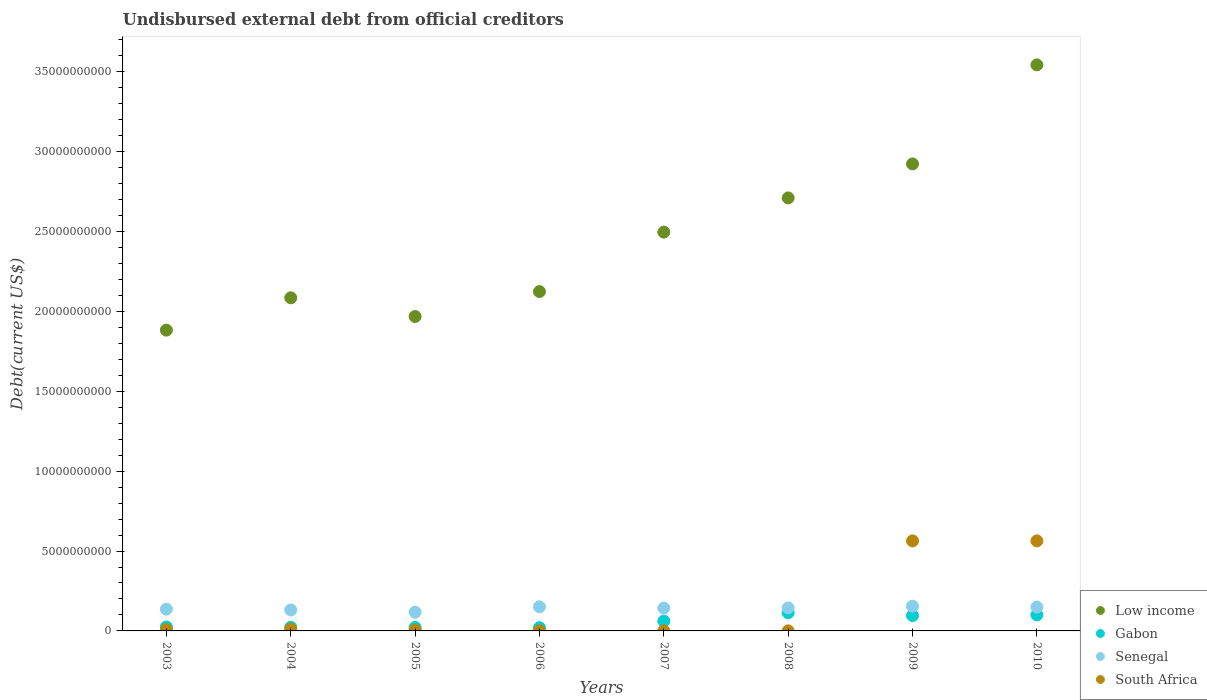What is the total debt in Gabon in 2004?
Offer a terse response. 2.28e+08. Across all years, what is the maximum total debt in Senegal?
Provide a succinct answer. 1.55e+09. Across all years, what is the minimum total debt in South Africa?
Provide a short and direct response. 3.94e+06. In which year was the total debt in Senegal minimum?
Provide a short and direct response. 2005. What is the total total debt in Gabon in the graph?
Provide a short and direct response. 4.61e+09. What is the difference between the total debt in Senegal in 2003 and that in 2004?
Your answer should be very brief. 5.16e+07. What is the difference between the total debt in Senegal in 2004 and the total debt in Gabon in 2009?
Your answer should be very brief. 3.48e+08. What is the average total debt in Senegal per year?
Provide a short and direct response. 1.41e+09. In the year 2005, what is the difference between the total debt in Low income and total debt in Gabon?
Keep it short and to the point. 1.95e+1. What is the ratio of the total debt in South Africa in 2007 to that in 2008?
Provide a succinct answer. 1.79. Is the total debt in Gabon in 2003 less than that in 2004?
Your answer should be very brief. No. What is the difference between the highest and the second highest total debt in Gabon?
Offer a terse response. 1.39e+08. What is the difference between the highest and the lowest total debt in Senegal?
Give a very brief answer. 3.78e+08. Is the sum of the total debt in Senegal in 2003 and 2006 greater than the maximum total debt in Low income across all years?
Offer a terse response. No. Is it the case that in every year, the sum of the total debt in Low income and total debt in South Africa  is greater than the total debt in Gabon?
Make the answer very short. Yes. Does the total debt in Gabon monotonically increase over the years?
Your response must be concise. No. Is the total debt in Senegal strictly greater than the total debt in South Africa over the years?
Offer a terse response. No. How many dotlines are there?
Your answer should be compact. 4. How many years are there in the graph?
Make the answer very short. 8. Does the graph contain grids?
Your answer should be very brief. No. Where does the legend appear in the graph?
Keep it short and to the point. Bottom right. How many legend labels are there?
Offer a terse response. 4. How are the legend labels stacked?
Your response must be concise. Vertical. What is the title of the graph?
Your response must be concise. Undisbursed external debt from official creditors. Does "Congo (Republic)" appear as one of the legend labels in the graph?
Your answer should be compact. No. What is the label or title of the Y-axis?
Ensure brevity in your answer.  Debt(current US$). What is the Debt(current US$) in Low income in 2003?
Your answer should be very brief. 1.88e+1. What is the Debt(current US$) in Gabon in 2003?
Offer a terse response. 2.49e+08. What is the Debt(current US$) of Senegal in 2003?
Give a very brief answer. 1.36e+09. What is the Debt(current US$) in South Africa in 2003?
Give a very brief answer. 8.62e+07. What is the Debt(current US$) of Low income in 2004?
Your answer should be very brief. 2.09e+1. What is the Debt(current US$) of Gabon in 2004?
Your response must be concise. 2.28e+08. What is the Debt(current US$) of Senegal in 2004?
Offer a very short reply. 1.31e+09. What is the Debt(current US$) in South Africa in 2004?
Make the answer very short. 1.16e+08. What is the Debt(current US$) of Low income in 2005?
Keep it short and to the point. 1.97e+1. What is the Debt(current US$) of Gabon in 2005?
Offer a terse response. 2.15e+08. What is the Debt(current US$) of Senegal in 2005?
Ensure brevity in your answer.  1.17e+09. What is the Debt(current US$) of South Africa in 2005?
Your answer should be compact. 5.70e+07. What is the Debt(current US$) of Low income in 2006?
Your answer should be very brief. 2.12e+1. What is the Debt(current US$) in Gabon in 2006?
Offer a terse response. 2.02e+08. What is the Debt(current US$) in Senegal in 2006?
Give a very brief answer. 1.51e+09. What is the Debt(current US$) of South Africa in 2006?
Make the answer very short. 7.04e+06. What is the Debt(current US$) of Low income in 2007?
Provide a short and direct response. 2.50e+1. What is the Debt(current US$) of Gabon in 2007?
Your answer should be compact. 6.12e+08. What is the Debt(current US$) of Senegal in 2007?
Keep it short and to the point. 1.43e+09. What is the Debt(current US$) of South Africa in 2007?
Make the answer very short. 7.04e+06. What is the Debt(current US$) of Low income in 2008?
Make the answer very short. 2.71e+1. What is the Debt(current US$) of Gabon in 2008?
Offer a terse response. 1.14e+09. What is the Debt(current US$) of Senegal in 2008?
Provide a short and direct response. 1.44e+09. What is the Debt(current US$) of South Africa in 2008?
Keep it short and to the point. 3.94e+06. What is the Debt(current US$) of Low income in 2009?
Your response must be concise. 2.92e+1. What is the Debt(current US$) in Gabon in 2009?
Offer a terse response. 9.63e+08. What is the Debt(current US$) of Senegal in 2009?
Give a very brief answer. 1.55e+09. What is the Debt(current US$) of South Africa in 2009?
Ensure brevity in your answer.  5.64e+09. What is the Debt(current US$) of Low income in 2010?
Your answer should be very brief. 3.54e+1. What is the Debt(current US$) of Gabon in 2010?
Give a very brief answer. 1.00e+09. What is the Debt(current US$) in Senegal in 2010?
Your answer should be very brief. 1.49e+09. What is the Debt(current US$) of South Africa in 2010?
Ensure brevity in your answer.  5.64e+09. Across all years, what is the maximum Debt(current US$) of Low income?
Your response must be concise. 3.54e+1. Across all years, what is the maximum Debt(current US$) of Gabon?
Provide a short and direct response. 1.14e+09. Across all years, what is the maximum Debt(current US$) of Senegal?
Your answer should be compact. 1.55e+09. Across all years, what is the maximum Debt(current US$) of South Africa?
Keep it short and to the point. 5.64e+09. Across all years, what is the minimum Debt(current US$) in Low income?
Offer a very short reply. 1.88e+1. Across all years, what is the minimum Debt(current US$) of Gabon?
Your response must be concise. 2.02e+08. Across all years, what is the minimum Debt(current US$) in Senegal?
Ensure brevity in your answer.  1.17e+09. Across all years, what is the minimum Debt(current US$) of South Africa?
Make the answer very short. 3.94e+06. What is the total Debt(current US$) in Low income in the graph?
Keep it short and to the point. 1.97e+11. What is the total Debt(current US$) in Gabon in the graph?
Your answer should be very brief. 4.61e+09. What is the total Debt(current US$) of Senegal in the graph?
Provide a succinct answer. 1.13e+1. What is the total Debt(current US$) of South Africa in the graph?
Offer a very short reply. 1.16e+1. What is the difference between the Debt(current US$) of Low income in 2003 and that in 2004?
Offer a very short reply. -2.02e+09. What is the difference between the Debt(current US$) of Gabon in 2003 and that in 2004?
Offer a terse response. 2.06e+07. What is the difference between the Debt(current US$) in Senegal in 2003 and that in 2004?
Make the answer very short. 5.16e+07. What is the difference between the Debt(current US$) of South Africa in 2003 and that in 2004?
Provide a succinct answer. -3.02e+07. What is the difference between the Debt(current US$) of Low income in 2003 and that in 2005?
Your response must be concise. -8.53e+08. What is the difference between the Debt(current US$) of Gabon in 2003 and that in 2005?
Your answer should be compact. 3.31e+07. What is the difference between the Debt(current US$) of Senegal in 2003 and that in 2005?
Offer a terse response. 1.92e+08. What is the difference between the Debt(current US$) in South Africa in 2003 and that in 2005?
Ensure brevity in your answer.  2.91e+07. What is the difference between the Debt(current US$) in Low income in 2003 and that in 2006?
Offer a very short reply. -2.41e+09. What is the difference between the Debt(current US$) in Gabon in 2003 and that in 2006?
Provide a succinct answer. 4.68e+07. What is the difference between the Debt(current US$) in Senegal in 2003 and that in 2006?
Provide a succinct answer. -1.49e+08. What is the difference between the Debt(current US$) of South Africa in 2003 and that in 2006?
Make the answer very short. 7.91e+07. What is the difference between the Debt(current US$) of Low income in 2003 and that in 2007?
Provide a succinct answer. -6.13e+09. What is the difference between the Debt(current US$) in Gabon in 2003 and that in 2007?
Offer a terse response. -3.63e+08. What is the difference between the Debt(current US$) of Senegal in 2003 and that in 2007?
Provide a succinct answer. -7.01e+07. What is the difference between the Debt(current US$) of South Africa in 2003 and that in 2007?
Give a very brief answer. 7.91e+07. What is the difference between the Debt(current US$) in Low income in 2003 and that in 2008?
Give a very brief answer. -8.28e+09. What is the difference between the Debt(current US$) of Gabon in 2003 and that in 2008?
Offer a terse response. -8.93e+08. What is the difference between the Debt(current US$) in Senegal in 2003 and that in 2008?
Offer a terse response. -7.77e+07. What is the difference between the Debt(current US$) in South Africa in 2003 and that in 2008?
Make the answer very short. 8.22e+07. What is the difference between the Debt(current US$) of Low income in 2003 and that in 2009?
Your answer should be very brief. -1.04e+1. What is the difference between the Debt(current US$) of Gabon in 2003 and that in 2009?
Ensure brevity in your answer.  -7.14e+08. What is the difference between the Debt(current US$) in Senegal in 2003 and that in 2009?
Provide a succinct answer. -1.86e+08. What is the difference between the Debt(current US$) in South Africa in 2003 and that in 2009?
Offer a terse response. -5.55e+09. What is the difference between the Debt(current US$) in Low income in 2003 and that in 2010?
Provide a short and direct response. -1.66e+1. What is the difference between the Debt(current US$) of Gabon in 2003 and that in 2010?
Your response must be concise. -7.54e+08. What is the difference between the Debt(current US$) of Senegal in 2003 and that in 2010?
Your answer should be very brief. -1.30e+08. What is the difference between the Debt(current US$) of South Africa in 2003 and that in 2010?
Provide a short and direct response. -5.55e+09. What is the difference between the Debt(current US$) in Low income in 2004 and that in 2005?
Make the answer very short. 1.17e+09. What is the difference between the Debt(current US$) of Gabon in 2004 and that in 2005?
Offer a very short reply. 1.24e+07. What is the difference between the Debt(current US$) in Senegal in 2004 and that in 2005?
Keep it short and to the point. 1.40e+08. What is the difference between the Debt(current US$) in South Africa in 2004 and that in 2005?
Your answer should be very brief. 5.94e+07. What is the difference between the Debt(current US$) of Low income in 2004 and that in 2006?
Provide a succinct answer. -3.89e+08. What is the difference between the Debt(current US$) in Gabon in 2004 and that in 2006?
Offer a very short reply. 2.61e+07. What is the difference between the Debt(current US$) of Senegal in 2004 and that in 2006?
Make the answer very short. -2.00e+08. What is the difference between the Debt(current US$) of South Africa in 2004 and that in 2006?
Offer a very short reply. 1.09e+08. What is the difference between the Debt(current US$) in Low income in 2004 and that in 2007?
Keep it short and to the point. -4.11e+09. What is the difference between the Debt(current US$) of Gabon in 2004 and that in 2007?
Offer a very short reply. -3.84e+08. What is the difference between the Debt(current US$) in Senegal in 2004 and that in 2007?
Keep it short and to the point. -1.22e+08. What is the difference between the Debt(current US$) in South Africa in 2004 and that in 2007?
Make the answer very short. 1.09e+08. What is the difference between the Debt(current US$) in Low income in 2004 and that in 2008?
Ensure brevity in your answer.  -6.25e+09. What is the difference between the Debt(current US$) in Gabon in 2004 and that in 2008?
Ensure brevity in your answer.  -9.14e+08. What is the difference between the Debt(current US$) in Senegal in 2004 and that in 2008?
Give a very brief answer. -1.29e+08. What is the difference between the Debt(current US$) of South Africa in 2004 and that in 2008?
Offer a terse response. 1.12e+08. What is the difference between the Debt(current US$) in Low income in 2004 and that in 2009?
Your answer should be very brief. -8.38e+09. What is the difference between the Debt(current US$) in Gabon in 2004 and that in 2009?
Provide a short and direct response. -7.35e+08. What is the difference between the Debt(current US$) of Senegal in 2004 and that in 2009?
Offer a very short reply. -2.38e+08. What is the difference between the Debt(current US$) of South Africa in 2004 and that in 2009?
Keep it short and to the point. -5.52e+09. What is the difference between the Debt(current US$) in Low income in 2004 and that in 2010?
Your response must be concise. -1.46e+1. What is the difference between the Debt(current US$) in Gabon in 2004 and that in 2010?
Provide a short and direct response. -7.75e+08. What is the difference between the Debt(current US$) in Senegal in 2004 and that in 2010?
Your answer should be very brief. -1.81e+08. What is the difference between the Debt(current US$) in South Africa in 2004 and that in 2010?
Your response must be concise. -5.52e+09. What is the difference between the Debt(current US$) in Low income in 2005 and that in 2006?
Provide a succinct answer. -1.56e+09. What is the difference between the Debt(current US$) of Gabon in 2005 and that in 2006?
Make the answer very short. 1.37e+07. What is the difference between the Debt(current US$) in Senegal in 2005 and that in 2006?
Your answer should be very brief. -3.40e+08. What is the difference between the Debt(current US$) in Low income in 2005 and that in 2007?
Ensure brevity in your answer.  -5.28e+09. What is the difference between the Debt(current US$) in Gabon in 2005 and that in 2007?
Your answer should be very brief. -3.96e+08. What is the difference between the Debt(current US$) in Senegal in 2005 and that in 2007?
Provide a succinct answer. -2.62e+08. What is the difference between the Debt(current US$) in South Africa in 2005 and that in 2007?
Offer a very short reply. 5.00e+07. What is the difference between the Debt(current US$) in Low income in 2005 and that in 2008?
Make the answer very short. -7.42e+09. What is the difference between the Debt(current US$) of Gabon in 2005 and that in 2008?
Provide a succinct answer. -9.26e+08. What is the difference between the Debt(current US$) of Senegal in 2005 and that in 2008?
Your response must be concise. -2.70e+08. What is the difference between the Debt(current US$) of South Africa in 2005 and that in 2008?
Offer a terse response. 5.31e+07. What is the difference between the Debt(current US$) of Low income in 2005 and that in 2009?
Your response must be concise. -9.55e+09. What is the difference between the Debt(current US$) of Gabon in 2005 and that in 2009?
Offer a terse response. -7.47e+08. What is the difference between the Debt(current US$) in Senegal in 2005 and that in 2009?
Your response must be concise. -3.78e+08. What is the difference between the Debt(current US$) of South Africa in 2005 and that in 2009?
Ensure brevity in your answer.  -5.58e+09. What is the difference between the Debt(current US$) of Low income in 2005 and that in 2010?
Offer a terse response. -1.58e+1. What is the difference between the Debt(current US$) in Gabon in 2005 and that in 2010?
Your answer should be very brief. -7.87e+08. What is the difference between the Debt(current US$) in Senegal in 2005 and that in 2010?
Keep it short and to the point. -3.22e+08. What is the difference between the Debt(current US$) of South Africa in 2005 and that in 2010?
Provide a short and direct response. -5.58e+09. What is the difference between the Debt(current US$) in Low income in 2006 and that in 2007?
Offer a terse response. -3.72e+09. What is the difference between the Debt(current US$) in Gabon in 2006 and that in 2007?
Your answer should be compact. -4.10e+08. What is the difference between the Debt(current US$) of Senegal in 2006 and that in 2007?
Give a very brief answer. 7.86e+07. What is the difference between the Debt(current US$) in South Africa in 2006 and that in 2007?
Make the answer very short. 0. What is the difference between the Debt(current US$) in Low income in 2006 and that in 2008?
Your answer should be very brief. -5.86e+09. What is the difference between the Debt(current US$) in Gabon in 2006 and that in 2008?
Provide a short and direct response. -9.40e+08. What is the difference between the Debt(current US$) in Senegal in 2006 and that in 2008?
Provide a succinct answer. 7.10e+07. What is the difference between the Debt(current US$) of South Africa in 2006 and that in 2008?
Offer a very short reply. 3.10e+06. What is the difference between the Debt(current US$) in Low income in 2006 and that in 2009?
Offer a very short reply. -7.99e+09. What is the difference between the Debt(current US$) of Gabon in 2006 and that in 2009?
Provide a succinct answer. -7.61e+08. What is the difference between the Debt(current US$) in Senegal in 2006 and that in 2009?
Keep it short and to the point. -3.77e+07. What is the difference between the Debt(current US$) of South Africa in 2006 and that in 2009?
Offer a terse response. -5.63e+09. What is the difference between the Debt(current US$) of Low income in 2006 and that in 2010?
Ensure brevity in your answer.  -1.42e+1. What is the difference between the Debt(current US$) of Gabon in 2006 and that in 2010?
Your answer should be very brief. -8.01e+08. What is the difference between the Debt(current US$) in Senegal in 2006 and that in 2010?
Your answer should be very brief. 1.87e+07. What is the difference between the Debt(current US$) in South Africa in 2006 and that in 2010?
Offer a terse response. -5.63e+09. What is the difference between the Debt(current US$) in Low income in 2007 and that in 2008?
Keep it short and to the point. -2.14e+09. What is the difference between the Debt(current US$) in Gabon in 2007 and that in 2008?
Provide a short and direct response. -5.30e+08. What is the difference between the Debt(current US$) of Senegal in 2007 and that in 2008?
Your answer should be compact. -7.61e+06. What is the difference between the Debt(current US$) in South Africa in 2007 and that in 2008?
Provide a succinct answer. 3.10e+06. What is the difference between the Debt(current US$) in Low income in 2007 and that in 2009?
Your response must be concise. -4.27e+09. What is the difference between the Debt(current US$) in Gabon in 2007 and that in 2009?
Offer a very short reply. -3.51e+08. What is the difference between the Debt(current US$) of Senegal in 2007 and that in 2009?
Give a very brief answer. -1.16e+08. What is the difference between the Debt(current US$) in South Africa in 2007 and that in 2009?
Give a very brief answer. -5.63e+09. What is the difference between the Debt(current US$) in Low income in 2007 and that in 2010?
Make the answer very short. -1.05e+1. What is the difference between the Debt(current US$) in Gabon in 2007 and that in 2010?
Provide a succinct answer. -3.91e+08. What is the difference between the Debt(current US$) in Senegal in 2007 and that in 2010?
Provide a short and direct response. -5.98e+07. What is the difference between the Debt(current US$) of South Africa in 2007 and that in 2010?
Make the answer very short. -5.63e+09. What is the difference between the Debt(current US$) in Low income in 2008 and that in 2009?
Provide a short and direct response. -2.13e+09. What is the difference between the Debt(current US$) of Gabon in 2008 and that in 2009?
Your response must be concise. 1.79e+08. What is the difference between the Debt(current US$) in Senegal in 2008 and that in 2009?
Your answer should be very brief. -1.09e+08. What is the difference between the Debt(current US$) of South Africa in 2008 and that in 2009?
Your response must be concise. -5.63e+09. What is the difference between the Debt(current US$) of Low income in 2008 and that in 2010?
Provide a succinct answer. -8.33e+09. What is the difference between the Debt(current US$) in Gabon in 2008 and that in 2010?
Give a very brief answer. 1.39e+08. What is the difference between the Debt(current US$) of Senegal in 2008 and that in 2010?
Keep it short and to the point. -5.22e+07. What is the difference between the Debt(current US$) in South Africa in 2008 and that in 2010?
Offer a very short reply. -5.63e+09. What is the difference between the Debt(current US$) in Low income in 2009 and that in 2010?
Provide a short and direct response. -6.20e+09. What is the difference between the Debt(current US$) in Gabon in 2009 and that in 2010?
Provide a succinct answer. -4.02e+07. What is the difference between the Debt(current US$) of Senegal in 2009 and that in 2010?
Your answer should be compact. 5.64e+07. What is the difference between the Debt(current US$) in South Africa in 2009 and that in 2010?
Your answer should be very brief. -1.40e+06. What is the difference between the Debt(current US$) in Low income in 2003 and the Debt(current US$) in Gabon in 2004?
Give a very brief answer. 1.86e+1. What is the difference between the Debt(current US$) of Low income in 2003 and the Debt(current US$) of Senegal in 2004?
Ensure brevity in your answer.  1.75e+1. What is the difference between the Debt(current US$) of Low income in 2003 and the Debt(current US$) of South Africa in 2004?
Provide a short and direct response. 1.87e+1. What is the difference between the Debt(current US$) of Gabon in 2003 and the Debt(current US$) of Senegal in 2004?
Your response must be concise. -1.06e+09. What is the difference between the Debt(current US$) in Gabon in 2003 and the Debt(current US$) in South Africa in 2004?
Offer a very short reply. 1.32e+08. What is the difference between the Debt(current US$) of Senegal in 2003 and the Debt(current US$) of South Africa in 2004?
Ensure brevity in your answer.  1.25e+09. What is the difference between the Debt(current US$) in Low income in 2003 and the Debt(current US$) in Gabon in 2005?
Your answer should be very brief. 1.86e+1. What is the difference between the Debt(current US$) of Low income in 2003 and the Debt(current US$) of Senegal in 2005?
Keep it short and to the point. 1.77e+1. What is the difference between the Debt(current US$) in Low income in 2003 and the Debt(current US$) in South Africa in 2005?
Provide a short and direct response. 1.88e+1. What is the difference between the Debt(current US$) in Gabon in 2003 and the Debt(current US$) in Senegal in 2005?
Make the answer very short. -9.22e+08. What is the difference between the Debt(current US$) in Gabon in 2003 and the Debt(current US$) in South Africa in 2005?
Your answer should be compact. 1.92e+08. What is the difference between the Debt(current US$) of Senegal in 2003 and the Debt(current US$) of South Africa in 2005?
Offer a very short reply. 1.31e+09. What is the difference between the Debt(current US$) of Low income in 2003 and the Debt(current US$) of Gabon in 2006?
Your response must be concise. 1.86e+1. What is the difference between the Debt(current US$) in Low income in 2003 and the Debt(current US$) in Senegal in 2006?
Offer a very short reply. 1.73e+1. What is the difference between the Debt(current US$) in Low income in 2003 and the Debt(current US$) in South Africa in 2006?
Your response must be concise. 1.88e+1. What is the difference between the Debt(current US$) in Gabon in 2003 and the Debt(current US$) in Senegal in 2006?
Your answer should be very brief. -1.26e+09. What is the difference between the Debt(current US$) of Gabon in 2003 and the Debt(current US$) of South Africa in 2006?
Make the answer very short. 2.42e+08. What is the difference between the Debt(current US$) in Senegal in 2003 and the Debt(current US$) in South Africa in 2006?
Provide a succinct answer. 1.36e+09. What is the difference between the Debt(current US$) of Low income in 2003 and the Debt(current US$) of Gabon in 2007?
Provide a succinct answer. 1.82e+1. What is the difference between the Debt(current US$) of Low income in 2003 and the Debt(current US$) of Senegal in 2007?
Make the answer very short. 1.74e+1. What is the difference between the Debt(current US$) in Low income in 2003 and the Debt(current US$) in South Africa in 2007?
Offer a very short reply. 1.88e+1. What is the difference between the Debt(current US$) of Gabon in 2003 and the Debt(current US$) of Senegal in 2007?
Provide a short and direct response. -1.18e+09. What is the difference between the Debt(current US$) in Gabon in 2003 and the Debt(current US$) in South Africa in 2007?
Your response must be concise. 2.42e+08. What is the difference between the Debt(current US$) in Senegal in 2003 and the Debt(current US$) in South Africa in 2007?
Give a very brief answer. 1.36e+09. What is the difference between the Debt(current US$) in Low income in 2003 and the Debt(current US$) in Gabon in 2008?
Offer a terse response. 1.77e+1. What is the difference between the Debt(current US$) in Low income in 2003 and the Debt(current US$) in Senegal in 2008?
Provide a succinct answer. 1.74e+1. What is the difference between the Debt(current US$) in Low income in 2003 and the Debt(current US$) in South Africa in 2008?
Provide a succinct answer. 1.88e+1. What is the difference between the Debt(current US$) of Gabon in 2003 and the Debt(current US$) of Senegal in 2008?
Keep it short and to the point. -1.19e+09. What is the difference between the Debt(current US$) of Gabon in 2003 and the Debt(current US$) of South Africa in 2008?
Offer a terse response. 2.45e+08. What is the difference between the Debt(current US$) in Senegal in 2003 and the Debt(current US$) in South Africa in 2008?
Give a very brief answer. 1.36e+09. What is the difference between the Debt(current US$) in Low income in 2003 and the Debt(current US$) in Gabon in 2009?
Keep it short and to the point. 1.79e+1. What is the difference between the Debt(current US$) in Low income in 2003 and the Debt(current US$) in Senegal in 2009?
Offer a very short reply. 1.73e+1. What is the difference between the Debt(current US$) of Low income in 2003 and the Debt(current US$) of South Africa in 2009?
Ensure brevity in your answer.  1.32e+1. What is the difference between the Debt(current US$) in Gabon in 2003 and the Debt(current US$) in Senegal in 2009?
Ensure brevity in your answer.  -1.30e+09. What is the difference between the Debt(current US$) in Gabon in 2003 and the Debt(current US$) in South Africa in 2009?
Offer a terse response. -5.39e+09. What is the difference between the Debt(current US$) of Senegal in 2003 and the Debt(current US$) of South Africa in 2009?
Your response must be concise. -4.27e+09. What is the difference between the Debt(current US$) in Low income in 2003 and the Debt(current US$) in Gabon in 2010?
Provide a short and direct response. 1.78e+1. What is the difference between the Debt(current US$) of Low income in 2003 and the Debt(current US$) of Senegal in 2010?
Your answer should be very brief. 1.73e+1. What is the difference between the Debt(current US$) in Low income in 2003 and the Debt(current US$) in South Africa in 2010?
Your answer should be compact. 1.32e+1. What is the difference between the Debt(current US$) of Gabon in 2003 and the Debt(current US$) of Senegal in 2010?
Ensure brevity in your answer.  -1.24e+09. What is the difference between the Debt(current US$) of Gabon in 2003 and the Debt(current US$) of South Africa in 2010?
Keep it short and to the point. -5.39e+09. What is the difference between the Debt(current US$) of Senegal in 2003 and the Debt(current US$) of South Africa in 2010?
Ensure brevity in your answer.  -4.27e+09. What is the difference between the Debt(current US$) in Low income in 2004 and the Debt(current US$) in Gabon in 2005?
Give a very brief answer. 2.06e+1. What is the difference between the Debt(current US$) of Low income in 2004 and the Debt(current US$) of Senegal in 2005?
Keep it short and to the point. 1.97e+1. What is the difference between the Debt(current US$) in Low income in 2004 and the Debt(current US$) in South Africa in 2005?
Your answer should be compact. 2.08e+1. What is the difference between the Debt(current US$) in Gabon in 2004 and the Debt(current US$) in Senegal in 2005?
Ensure brevity in your answer.  -9.43e+08. What is the difference between the Debt(current US$) in Gabon in 2004 and the Debt(current US$) in South Africa in 2005?
Provide a succinct answer. 1.71e+08. What is the difference between the Debt(current US$) in Senegal in 2004 and the Debt(current US$) in South Africa in 2005?
Make the answer very short. 1.25e+09. What is the difference between the Debt(current US$) of Low income in 2004 and the Debt(current US$) of Gabon in 2006?
Offer a very short reply. 2.07e+1. What is the difference between the Debt(current US$) of Low income in 2004 and the Debt(current US$) of Senegal in 2006?
Give a very brief answer. 1.93e+1. What is the difference between the Debt(current US$) of Low income in 2004 and the Debt(current US$) of South Africa in 2006?
Offer a very short reply. 2.08e+1. What is the difference between the Debt(current US$) of Gabon in 2004 and the Debt(current US$) of Senegal in 2006?
Provide a short and direct response. -1.28e+09. What is the difference between the Debt(current US$) of Gabon in 2004 and the Debt(current US$) of South Africa in 2006?
Your answer should be very brief. 2.21e+08. What is the difference between the Debt(current US$) of Senegal in 2004 and the Debt(current US$) of South Africa in 2006?
Your response must be concise. 1.30e+09. What is the difference between the Debt(current US$) in Low income in 2004 and the Debt(current US$) in Gabon in 2007?
Provide a short and direct response. 2.02e+1. What is the difference between the Debt(current US$) of Low income in 2004 and the Debt(current US$) of Senegal in 2007?
Your answer should be very brief. 1.94e+1. What is the difference between the Debt(current US$) of Low income in 2004 and the Debt(current US$) of South Africa in 2007?
Give a very brief answer. 2.08e+1. What is the difference between the Debt(current US$) of Gabon in 2004 and the Debt(current US$) of Senegal in 2007?
Make the answer very short. -1.20e+09. What is the difference between the Debt(current US$) of Gabon in 2004 and the Debt(current US$) of South Africa in 2007?
Your response must be concise. 2.21e+08. What is the difference between the Debt(current US$) in Senegal in 2004 and the Debt(current US$) in South Africa in 2007?
Offer a terse response. 1.30e+09. What is the difference between the Debt(current US$) of Low income in 2004 and the Debt(current US$) of Gabon in 2008?
Offer a terse response. 1.97e+1. What is the difference between the Debt(current US$) in Low income in 2004 and the Debt(current US$) in Senegal in 2008?
Provide a short and direct response. 1.94e+1. What is the difference between the Debt(current US$) of Low income in 2004 and the Debt(current US$) of South Africa in 2008?
Offer a very short reply. 2.09e+1. What is the difference between the Debt(current US$) in Gabon in 2004 and the Debt(current US$) in Senegal in 2008?
Provide a short and direct response. -1.21e+09. What is the difference between the Debt(current US$) of Gabon in 2004 and the Debt(current US$) of South Africa in 2008?
Provide a succinct answer. 2.24e+08. What is the difference between the Debt(current US$) in Senegal in 2004 and the Debt(current US$) in South Africa in 2008?
Make the answer very short. 1.31e+09. What is the difference between the Debt(current US$) of Low income in 2004 and the Debt(current US$) of Gabon in 2009?
Make the answer very short. 1.99e+1. What is the difference between the Debt(current US$) in Low income in 2004 and the Debt(current US$) in Senegal in 2009?
Make the answer very short. 1.93e+1. What is the difference between the Debt(current US$) in Low income in 2004 and the Debt(current US$) in South Africa in 2009?
Your answer should be compact. 1.52e+1. What is the difference between the Debt(current US$) of Gabon in 2004 and the Debt(current US$) of Senegal in 2009?
Give a very brief answer. -1.32e+09. What is the difference between the Debt(current US$) in Gabon in 2004 and the Debt(current US$) in South Africa in 2009?
Provide a succinct answer. -5.41e+09. What is the difference between the Debt(current US$) of Senegal in 2004 and the Debt(current US$) of South Africa in 2009?
Your answer should be compact. -4.33e+09. What is the difference between the Debt(current US$) of Low income in 2004 and the Debt(current US$) of Gabon in 2010?
Your answer should be compact. 1.99e+1. What is the difference between the Debt(current US$) of Low income in 2004 and the Debt(current US$) of Senegal in 2010?
Your response must be concise. 1.94e+1. What is the difference between the Debt(current US$) of Low income in 2004 and the Debt(current US$) of South Africa in 2010?
Offer a terse response. 1.52e+1. What is the difference between the Debt(current US$) of Gabon in 2004 and the Debt(current US$) of Senegal in 2010?
Your answer should be very brief. -1.26e+09. What is the difference between the Debt(current US$) of Gabon in 2004 and the Debt(current US$) of South Africa in 2010?
Make the answer very short. -5.41e+09. What is the difference between the Debt(current US$) in Senegal in 2004 and the Debt(current US$) in South Africa in 2010?
Provide a short and direct response. -4.33e+09. What is the difference between the Debt(current US$) in Low income in 2005 and the Debt(current US$) in Gabon in 2006?
Your answer should be compact. 1.95e+1. What is the difference between the Debt(current US$) of Low income in 2005 and the Debt(current US$) of Senegal in 2006?
Give a very brief answer. 1.82e+1. What is the difference between the Debt(current US$) of Low income in 2005 and the Debt(current US$) of South Africa in 2006?
Provide a short and direct response. 1.97e+1. What is the difference between the Debt(current US$) of Gabon in 2005 and the Debt(current US$) of Senegal in 2006?
Offer a terse response. -1.30e+09. What is the difference between the Debt(current US$) in Gabon in 2005 and the Debt(current US$) in South Africa in 2006?
Your answer should be compact. 2.08e+08. What is the difference between the Debt(current US$) of Senegal in 2005 and the Debt(current US$) of South Africa in 2006?
Provide a succinct answer. 1.16e+09. What is the difference between the Debt(current US$) of Low income in 2005 and the Debt(current US$) of Gabon in 2007?
Ensure brevity in your answer.  1.91e+1. What is the difference between the Debt(current US$) of Low income in 2005 and the Debt(current US$) of Senegal in 2007?
Make the answer very short. 1.83e+1. What is the difference between the Debt(current US$) in Low income in 2005 and the Debt(current US$) in South Africa in 2007?
Give a very brief answer. 1.97e+1. What is the difference between the Debt(current US$) of Gabon in 2005 and the Debt(current US$) of Senegal in 2007?
Offer a very short reply. -1.22e+09. What is the difference between the Debt(current US$) of Gabon in 2005 and the Debt(current US$) of South Africa in 2007?
Your response must be concise. 2.08e+08. What is the difference between the Debt(current US$) in Senegal in 2005 and the Debt(current US$) in South Africa in 2007?
Provide a succinct answer. 1.16e+09. What is the difference between the Debt(current US$) of Low income in 2005 and the Debt(current US$) of Gabon in 2008?
Keep it short and to the point. 1.85e+1. What is the difference between the Debt(current US$) of Low income in 2005 and the Debt(current US$) of Senegal in 2008?
Provide a succinct answer. 1.82e+1. What is the difference between the Debt(current US$) of Low income in 2005 and the Debt(current US$) of South Africa in 2008?
Keep it short and to the point. 1.97e+1. What is the difference between the Debt(current US$) in Gabon in 2005 and the Debt(current US$) in Senegal in 2008?
Provide a short and direct response. -1.22e+09. What is the difference between the Debt(current US$) of Gabon in 2005 and the Debt(current US$) of South Africa in 2008?
Provide a short and direct response. 2.12e+08. What is the difference between the Debt(current US$) in Senegal in 2005 and the Debt(current US$) in South Africa in 2008?
Provide a short and direct response. 1.17e+09. What is the difference between the Debt(current US$) of Low income in 2005 and the Debt(current US$) of Gabon in 2009?
Your response must be concise. 1.87e+1. What is the difference between the Debt(current US$) of Low income in 2005 and the Debt(current US$) of Senegal in 2009?
Give a very brief answer. 1.81e+1. What is the difference between the Debt(current US$) of Low income in 2005 and the Debt(current US$) of South Africa in 2009?
Make the answer very short. 1.40e+1. What is the difference between the Debt(current US$) in Gabon in 2005 and the Debt(current US$) in Senegal in 2009?
Make the answer very short. -1.33e+09. What is the difference between the Debt(current US$) in Gabon in 2005 and the Debt(current US$) in South Africa in 2009?
Offer a very short reply. -5.42e+09. What is the difference between the Debt(current US$) of Senegal in 2005 and the Debt(current US$) of South Africa in 2009?
Give a very brief answer. -4.47e+09. What is the difference between the Debt(current US$) in Low income in 2005 and the Debt(current US$) in Gabon in 2010?
Offer a very short reply. 1.87e+1. What is the difference between the Debt(current US$) of Low income in 2005 and the Debt(current US$) of Senegal in 2010?
Ensure brevity in your answer.  1.82e+1. What is the difference between the Debt(current US$) in Low income in 2005 and the Debt(current US$) in South Africa in 2010?
Give a very brief answer. 1.40e+1. What is the difference between the Debt(current US$) in Gabon in 2005 and the Debt(current US$) in Senegal in 2010?
Offer a terse response. -1.28e+09. What is the difference between the Debt(current US$) of Gabon in 2005 and the Debt(current US$) of South Africa in 2010?
Provide a short and direct response. -5.42e+09. What is the difference between the Debt(current US$) in Senegal in 2005 and the Debt(current US$) in South Africa in 2010?
Ensure brevity in your answer.  -4.47e+09. What is the difference between the Debt(current US$) of Low income in 2006 and the Debt(current US$) of Gabon in 2007?
Your response must be concise. 2.06e+1. What is the difference between the Debt(current US$) of Low income in 2006 and the Debt(current US$) of Senegal in 2007?
Offer a very short reply. 1.98e+1. What is the difference between the Debt(current US$) in Low income in 2006 and the Debt(current US$) in South Africa in 2007?
Give a very brief answer. 2.12e+1. What is the difference between the Debt(current US$) of Gabon in 2006 and the Debt(current US$) of Senegal in 2007?
Offer a very short reply. -1.23e+09. What is the difference between the Debt(current US$) of Gabon in 2006 and the Debt(current US$) of South Africa in 2007?
Your answer should be very brief. 1.95e+08. What is the difference between the Debt(current US$) in Senegal in 2006 and the Debt(current US$) in South Africa in 2007?
Provide a short and direct response. 1.50e+09. What is the difference between the Debt(current US$) of Low income in 2006 and the Debt(current US$) of Gabon in 2008?
Ensure brevity in your answer.  2.01e+1. What is the difference between the Debt(current US$) of Low income in 2006 and the Debt(current US$) of Senegal in 2008?
Offer a very short reply. 1.98e+1. What is the difference between the Debt(current US$) of Low income in 2006 and the Debt(current US$) of South Africa in 2008?
Offer a very short reply. 2.12e+1. What is the difference between the Debt(current US$) of Gabon in 2006 and the Debt(current US$) of Senegal in 2008?
Keep it short and to the point. -1.24e+09. What is the difference between the Debt(current US$) of Gabon in 2006 and the Debt(current US$) of South Africa in 2008?
Your response must be concise. 1.98e+08. What is the difference between the Debt(current US$) in Senegal in 2006 and the Debt(current US$) in South Africa in 2008?
Ensure brevity in your answer.  1.51e+09. What is the difference between the Debt(current US$) in Low income in 2006 and the Debt(current US$) in Gabon in 2009?
Make the answer very short. 2.03e+1. What is the difference between the Debt(current US$) of Low income in 2006 and the Debt(current US$) of Senegal in 2009?
Your response must be concise. 1.97e+1. What is the difference between the Debt(current US$) in Low income in 2006 and the Debt(current US$) in South Africa in 2009?
Ensure brevity in your answer.  1.56e+1. What is the difference between the Debt(current US$) in Gabon in 2006 and the Debt(current US$) in Senegal in 2009?
Your response must be concise. -1.35e+09. What is the difference between the Debt(current US$) of Gabon in 2006 and the Debt(current US$) of South Africa in 2009?
Your answer should be very brief. -5.43e+09. What is the difference between the Debt(current US$) in Senegal in 2006 and the Debt(current US$) in South Africa in 2009?
Offer a terse response. -4.12e+09. What is the difference between the Debt(current US$) in Low income in 2006 and the Debt(current US$) in Gabon in 2010?
Your response must be concise. 2.02e+1. What is the difference between the Debt(current US$) of Low income in 2006 and the Debt(current US$) of Senegal in 2010?
Offer a very short reply. 1.98e+1. What is the difference between the Debt(current US$) in Low income in 2006 and the Debt(current US$) in South Africa in 2010?
Provide a short and direct response. 1.56e+1. What is the difference between the Debt(current US$) in Gabon in 2006 and the Debt(current US$) in Senegal in 2010?
Offer a very short reply. -1.29e+09. What is the difference between the Debt(current US$) of Gabon in 2006 and the Debt(current US$) of South Africa in 2010?
Give a very brief answer. -5.44e+09. What is the difference between the Debt(current US$) of Senegal in 2006 and the Debt(current US$) of South Africa in 2010?
Offer a terse response. -4.13e+09. What is the difference between the Debt(current US$) of Low income in 2007 and the Debt(current US$) of Gabon in 2008?
Offer a very short reply. 2.38e+1. What is the difference between the Debt(current US$) in Low income in 2007 and the Debt(current US$) in Senegal in 2008?
Offer a terse response. 2.35e+1. What is the difference between the Debt(current US$) of Low income in 2007 and the Debt(current US$) of South Africa in 2008?
Offer a terse response. 2.50e+1. What is the difference between the Debt(current US$) of Gabon in 2007 and the Debt(current US$) of Senegal in 2008?
Offer a very short reply. -8.29e+08. What is the difference between the Debt(current US$) in Gabon in 2007 and the Debt(current US$) in South Africa in 2008?
Keep it short and to the point. 6.08e+08. What is the difference between the Debt(current US$) in Senegal in 2007 and the Debt(current US$) in South Africa in 2008?
Your answer should be compact. 1.43e+09. What is the difference between the Debt(current US$) of Low income in 2007 and the Debt(current US$) of Gabon in 2009?
Give a very brief answer. 2.40e+1. What is the difference between the Debt(current US$) of Low income in 2007 and the Debt(current US$) of Senegal in 2009?
Provide a succinct answer. 2.34e+1. What is the difference between the Debt(current US$) in Low income in 2007 and the Debt(current US$) in South Africa in 2009?
Make the answer very short. 1.93e+1. What is the difference between the Debt(current US$) of Gabon in 2007 and the Debt(current US$) of Senegal in 2009?
Provide a short and direct response. -9.37e+08. What is the difference between the Debt(current US$) in Gabon in 2007 and the Debt(current US$) in South Africa in 2009?
Give a very brief answer. -5.02e+09. What is the difference between the Debt(current US$) in Senegal in 2007 and the Debt(current US$) in South Africa in 2009?
Give a very brief answer. -4.20e+09. What is the difference between the Debt(current US$) in Low income in 2007 and the Debt(current US$) in Gabon in 2010?
Ensure brevity in your answer.  2.40e+1. What is the difference between the Debt(current US$) of Low income in 2007 and the Debt(current US$) of Senegal in 2010?
Give a very brief answer. 2.35e+1. What is the difference between the Debt(current US$) in Low income in 2007 and the Debt(current US$) in South Africa in 2010?
Provide a short and direct response. 1.93e+1. What is the difference between the Debt(current US$) in Gabon in 2007 and the Debt(current US$) in Senegal in 2010?
Your answer should be compact. -8.81e+08. What is the difference between the Debt(current US$) in Gabon in 2007 and the Debt(current US$) in South Africa in 2010?
Ensure brevity in your answer.  -5.03e+09. What is the difference between the Debt(current US$) in Senegal in 2007 and the Debt(current US$) in South Africa in 2010?
Offer a terse response. -4.20e+09. What is the difference between the Debt(current US$) of Low income in 2008 and the Debt(current US$) of Gabon in 2009?
Keep it short and to the point. 2.61e+1. What is the difference between the Debt(current US$) in Low income in 2008 and the Debt(current US$) in Senegal in 2009?
Keep it short and to the point. 2.56e+1. What is the difference between the Debt(current US$) in Low income in 2008 and the Debt(current US$) in South Africa in 2009?
Make the answer very short. 2.15e+1. What is the difference between the Debt(current US$) in Gabon in 2008 and the Debt(current US$) in Senegal in 2009?
Keep it short and to the point. -4.07e+08. What is the difference between the Debt(current US$) of Gabon in 2008 and the Debt(current US$) of South Africa in 2009?
Your response must be concise. -4.49e+09. What is the difference between the Debt(current US$) of Senegal in 2008 and the Debt(current US$) of South Africa in 2009?
Provide a short and direct response. -4.20e+09. What is the difference between the Debt(current US$) of Low income in 2008 and the Debt(current US$) of Gabon in 2010?
Provide a short and direct response. 2.61e+1. What is the difference between the Debt(current US$) in Low income in 2008 and the Debt(current US$) in Senegal in 2010?
Your answer should be compact. 2.56e+1. What is the difference between the Debt(current US$) of Low income in 2008 and the Debt(current US$) of South Africa in 2010?
Your response must be concise. 2.15e+1. What is the difference between the Debt(current US$) of Gabon in 2008 and the Debt(current US$) of Senegal in 2010?
Make the answer very short. -3.51e+08. What is the difference between the Debt(current US$) in Gabon in 2008 and the Debt(current US$) in South Africa in 2010?
Your answer should be very brief. -4.50e+09. What is the difference between the Debt(current US$) in Senegal in 2008 and the Debt(current US$) in South Africa in 2010?
Provide a succinct answer. -4.20e+09. What is the difference between the Debt(current US$) in Low income in 2009 and the Debt(current US$) in Gabon in 2010?
Provide a succinct answer. 2.82e+1. What is the difference between the Debt(current US$) in Low income in 2009 and the Debt(current US$) in Senegal in 2010?
Ensure brevity in your answer.  2.77e+1. What is the difference between the Debt(current US$) of Low income in 2009 and the Debt(current US$) of South Africa in 2010?
Give a very brief answer. 2.36e+1. What is the difference between the Debt(current US$) in Gabon in 2009 and the Debt(current US$) in Senegal in 2010?
Keep it short and to the point. -5.30e+08. What is the difference between the Debt(current US$) of Gabon in 2009 and the Debt(current US$) of South Africa in 2010?
Offer a very short reply. -4.68e+09. What is the difference between the Debt(current US$) of Senegal in 2009 and the Debt(current US$) of South Africa in 2010?
Keep it short and to the point. -4.09e+09. What is the average Debt(current US$) of Low income per year?
Offer a terse response. 2.47e+1. What is the average Debt(current US$) of Gabon per year?
Provide a succinct answer. 5.77e+08. What is the average Debt(current US$) of Senegal per year?
Your response must be concise. 1.41e+09. What is the average Debt(current US$) in South Africa per year?
Make the answer very short. 1.44e+09. In the year 2003, what is the difference between the Debt(current US$) in Low income and Debt(current US$) in Gabon?
Ensure brevity in your answer.  1.86e+1. In the year 2003, what is the difference between the Debt(current US$) in Low income and Debt(current US$) in Senegal?
Give a very brief answer. 1.75e+1. In the year 2003, what is the difference between the Debt(current US$) of Low income and Debt(current US$) of South Africa?
Give a very brief answer. 1.87e+1. In the year 2003, what is the difference between the Debt(current US$) of Gabon and Debt(current US$) of Senegal?
Your response must be concise. -1.11e+09. In the year 2003, what is the difference between the Debt(current US$) in Gabon and Debt(current US$) in South Africa?
Offer a very short reply. 1.62e+08. In the year 2003, what is the difference between the Debt(current US$) in Senegal and Debt(current US$) in South Africa?
Give a very brief answer. 1.28e+09. In the year 2004, what is the difference between the Debt(current US$) of Low income and Debt(current US$) of Gabon?
Your response must be concise. 2.06e+1. In the year 2004, what is the difference between the Debt(current US$) of Low income and Debt(current US$) of Senegal?
Your answer should be very brief. 1.95e+1. In the year 2004, what is the difference between the Debt(current US$) in Low income and Debt(current US$) in South Africa?
Offer a very short reply. 2.07e+1. In the year 2004, what is the difference between the Debt(current US$) in Gabon and Debt(current US$) in Senegal?
Offer a very short reply. -1.08e+09. In the year 2004, what is the difference between the Debt(current US$) in Gabon and Debt(current US$) in South Africa?
Your answer should be compact. 1.12e+08. In the year 2004, what is the difference between the Debt(current US$) of Senegal and Debt(current US$) of South Africa?
Keep it short and to the point. 1.19e+09. In the year 2005, what is the difference between the Debt(current US$) of Low income and Debt(current US$) of Gabon?
Ensure brevity in your answer.  1.95e+1. In the year 2005, what is the difference between the Debt(current US$) in Low income and Debt(current US$) in Senegal?
Ensure brevity in your answer.  1.85e+1. In the year 2005, what is the difference between the Debt(current US$) in Low income and Debt(current US$) in South Africa?
Ensure brevity in your answer.  1.96e+1. In the year 2005, what is the difference between the Debt(current US$) of Gabon and Debt(current US$) of Senegal?
Your answer should be compact. -9.55e+08. In the year 2005, what is the difference between the Debt(current US$) of Gabon and Debt(current US$) of South Africa?
Provide a short and direct response. 1.58e+08. In the year 2005, what is the difference between the Debt(current US$) in Senegal and Debt(current US$) in South Africa?
Ensure brevity in your answer.  1.11e+09. In the year 2006, what is the difference between the Debt(current US$) in Low income and Debt(current US$) in Gabon?
Provide a succinct answer. 2.10e+1. In the year 2006, what is the difference between the Debt(current US$) of Low income and Debt(current US$) of Senegal?
Provide a succinct answer. 1.97e+1. In the year 2006, what is the difference between the Debt(current US$) of Low income and Debt(current US$) of South Africa?
Offer a terse response. 2.12e+1. In the year 2006, what is the difference between the Debt(current US$) of Gabon and Debt(current US$) of Senegal?
Provide a succinct answer. -1.31e+09. In the year 2006, what is the difference between the Debt(current US$) in Gabon and Debt(current US$) in South Africa?
Keep it short and to the point. 1.95e+08. In the year 2006, what is the difference between the Debt(current US$) in Senegal and Debt(current US$) in South Africa?
Provide a succinct answer. 1.50e+09. In the year 2007, what is the difference between the Debt(current US$) of Low income and Debt(current US$) of Gabon?
Keep it short and to the point. 2.44e+1. In the year 2007, what is the difference between the Debt(current US$) in Low income and Debt(current US$) in Senegal?
Give a very brief answer. 2.35e+1. In the year 2007, what is the difference between the Debt(current US$) in Low income and Debt(current US$) in South Africa?
Offer a terse response. 2.50e+1. In the year 2007, what is the difference between the Debt(current US$) in Gabon and Debt(current US$) in Senegal?
Provide a short and direct response. -8.21e+08. In the year 2007, what is the difference between the Debt(current US$) in Gabon and Debt(current US$) in South Africa?
Make the answer very short. 6.05e+08. In the year 2007, what is the difference between the Debt(current US$) of Senegal and Debt(current US$) of South Africa?
Your response must be concise. 1.43e+09. In the year 2008, what is the difference between the Debt(current US$) in Low income and Debt(current US$) in Gabon?
Offer a very short reply. 2.60e+1. In the year 2008, what is the difference between the Debt(current US$) in Low income and Debt(current US$) in Senegal?
Ensure brevity in your answer.  2.57e+1. In the year 2008, what is the difference between the Debt(current US$) of Low income and Debt(current US$) of South Africa?
Your response must be concise. 2.71e+1. In the year 2008, what is the difference between the Debt(current US$) in Gabon and Debt(current US$) in Senegal?
Offer a very short reply. -2.99e+08. In the year 2008, what is the difference between the Debt(current US$) in Gabon and Debt(current US$) in South Africa?
Keep it short and to the point. 1.14e+09. In the year 2008, what is the difference between the Debt(current US$) in Senegal and Debt(current US$) in South Africa?
Give a very brief answer. 1.44e+09. In the year 2009, what is the difference between the Debt(current US$) of Low income and Debt(current US$) of Gabon?
Offer a very short reply. 2.83e+1. In the year 2009, what is the difference between the Debt(current US$) in Low income and Debt(current US$) in Senegal?
Make the answer very short. 2.77e+1. In the year 2009, what is the difference between the Debt(current US$) in Low income and Debt(current US$) in South Africa?
Provide a succinct answer. 2.36e+1. In the year 2009, what is the difference between the Debt(current US$) in Gabon and Debt(current US$) in Senegal?
Offer a very short reply. -5.86e+08. In the year 2009, what is the difference between the Debt(current US$) in Gabon and Debt(current US$) in South Africa?
Your response must be concise. -4.67e+09. In the year 2009, what is the difference between the Debt(current US$) in Senegal and Debt(current US$) in South Africa?
Offer a very short reply. -4.09e+09. In the year 2010, what is the difference between the Debt(current US$) of Low income and Debt(current US$) of Gabon?
Keep it short and to the point. 3.44e+1. In the year 2010, what is the difference between the Debt(current US$) in Low income and Debt(current US$) in Senegal?
Give a very brief answer. 3.39e+1. In the year 2010, what is the difference between the Debt(current US$) in Low income and Debt(current US$) in South Africa?
Give a very brief answer. 2.98e+1. In the year 2010, what is the difference between the Debt(current US$) of Gabon and Debt(current US$) of Senegal?
Provide a short and direct response. -4.90e+08. In the year 2010, what is the difference between the Debt(current US$) in Gabon and Debt(current US$) in South Africa?
Offer a terse response. -4.63e+09. In the year 2010, what is the difference between the Debt(current US$) in Senegal and Debt(current US$) in South Africa?
Ensure brevity in your answer.  -4.15e+09. What is the ratio of the Debt(current US$) in Low income in 2003 to that in 2004?
Provide a succinct answer. 0.9. What is the ratio of the Debt(current US$) of Gabon in 2003 to that in 2004?
Provide a short and direct response. 1.09. What is the ratio of the Debt(current US$) of Senegal in 2003 to that in 2004?
Your answer should be very brief. 1.04. What is the ratio of the Debt(current US$) of South Africa in 2003 to that in 2004?
Offer a terse response. 0.74. What is the ratio of the Debt(current US$) in Low income in 2003 to that in 2005?
Make the answer very short. 0.96. What is the ratio of the Debt(current US$) in Gabon in 2003 to that in 2005?
Keep it short and to the point. 1.15. What is the ratio of the Debt(current US$) in Senegal in 2003 to that in 2005?
Give a very brief answer. 1.16. What is the ratio of the Debt(current US$) in South Africa in 2003 to that in 2005?
Make the answer very short. 1.51. What is the ratio of the Debt(current US$) of Low income in 2003 to that in 2006?
Provide a succinct answer. 0.89. What is the ratio of the Debt(current US$) in Gabon in 2003 to that in 2006?
Make the answer very short. 1.23. What is the ratio of the Debt(current US$) of Senegal in 2003 to that in 2006?
Offer a very short reply. 0.9. What is the ratio of the Debt(current US$) of South Africa in 2003 to that in 2006?
Your response must be concise. 12.24. What is the ratio of the Debt(current US$) in Low income in 2003 to that in 2007?
Offer a terse response. 0.75. What is the ratio of the Debt(current US$) in Gabon in 2003 to that in 2007?
Keep it short and to the point. 0.41. What is the ratio of the Debt(current US$) of Senegal in 2003 to that in 2007?
Make the answer very short. 0.95. What is the ratio of the Debt(current US$) of South Africa in 2003 to that in 2007?
Keep it short and to the point. 12.24. What is the ratio of the Debt(current US$) of Low income in 2003 to that in 2008?
Provide a succinct answer. 0.69. What is the ratio of the Debt(current US$) of Gabon in 2003 to that in 2008?
Ensure brevity in your answer.  0.22. What is the ratio of the Debt(current US$) of Senegal in 2003 to that in 2008?
Offer a terse response. 0.95. What is the ratio of the Debt(current US$) in South Africa in 2003 to that in 2008?
Your answer should be very brief. 21.9. What is the ratio of the Debt(current US$) of Low income in 2003 to that in 2009?
Your answer should be compact. 0.64. What is the ratio of the Debt(current US$) in Gabon in 2003 to that in 2009?
Make the answer very short. 0.26. What is the ratio of the Debt(current US$) in Senegal in 2003 to that in 2009?
Keep it short and to the point. 0.88. What is the ratio of the Debt(current US$) of South Africa in 2003 to that in 2009?
Provide a succinct answer. 0.02. What is the ratio of the Debt(current US$) of Low income in 2003 to that in 2010?
Give a very brief answer. 0.53. What is the ratio of the Debt(current US$) of Gabon in 2003 to that in 2010?
Offer a terse response. 0.25. What is the ratio of the Debt(current US$) in South Africa in 2003 to that in 2010?
Your answer should be compact. 0.02. What is the ratio of the Debt(current US$) of Low income in 2004 to that in 2005?
Your answer should be compact. 1.06. What is the ratio of the Debt(current US$) in Gabon in 2004 to that in 2005?
Provide a succinct answer. 1.06. What is the ratio of the Debt(current US$) in Senegal in 2004 to that in 2005?
Your answer should be very brief. 1.12. What is the ratio of the Debt(current US$) of South Africa in 2004 to that in 2005?
Your response must be concise. 2.04. What is the ratio of the Debt(current US$) in Low income in 2004 to that in 2006?
Make the answer very short. 0.98. What is the ratio of the Debt(current US$) in Gabon in 2004 to that in 2006?
Your response must be concise. 1.13. What is the ratio of the Debt(current US$) in Senegal in 2004 to that in 2006?
Ensure brevity in your answer.  0.87. What is the ratio of the Debt(current US$) in South Africa in 2004 to that in 2006?
Give a very brief answer. 16.54. What is the ratio of the Debt(current US$) of Low income in 2004 to that in 2007?
Give a very brief answer. 0.84. What is the ratio of the Debt(current US$) in Gabon in 2004 to that in 2007?
Ensure brevity in your answer.  0.37. What is the ratio of the Debt(current US$) of Senegal in 2004 to that in 2007?
Your response must be concise. 0.92. What is the ratio of the Debt(current US$) in South Africa in 2004 to that in 2007?
Offer a terse response. 16.54. What is the ratio of the Debt(current US$) of Low income in 2004 to that in 2008?
Provide a succinct answer. 0.77. What is the ratio of the Debt(current US$) in Gabon in 2004 to that in 2008?
Offer a terse response. 0.2. What is the ratio of the Debt(current US$) in Senegal in 2004 to that in 2008?
Offer a very short reply. 0.91. What is the ratio of the Debt(current US$) in South Africa in 2004 to that in 2008?
Provide a short and direct response. 29.58. What is the ratio of the Debt(current US$) of Low income in 2004 to that in 2009?
Make the answer very short. 0.71. What is the ratio of the Debt(current US$) in Gabon in 2004 to that in 2009?
Give a very brief answer. 0.24. What is the ratio of the Debt(current US$) in Senegal in 2004 to that in 2009?
Give a very brief answer. 0.85. What is the ratio of the Debt(current US$) of South Africa in 2004 to that in 2009?
Keep it short and to the point. 0.02. What is the ratio of the Debt(current US$) of Low income in 2004 to that in 2010?
Your response must be concise. 0.59. What is the ratio of the Debt(current US$) in Gabon in 2004 to that in 2010?
Your answer should be compact. 0.23. What is the ratio of the Debt(current US$) of Senegal in 2004 to that in 2010?
Your answer should be compact. 0.88. What is the ratio of the Debt(current US$) in South Africa in 2004 to that in 2010?
Your answer should be compact. 0.02. What is the ratio of the Debt(current US$) of Low income in 2005 to that in 2006?
Your response must be concise. 0.93. What is the ratio of the Debt(current US$) of Gabon in 2005 to that in 2006?
Offer a terse response. 1.07. What is the ratio of the Debt(current US$) of Senegal in 2005 to that in 2006?
Offer a terse response. 0.77. What is the ratio of the Debt(current US$) of South Africa in 2005 to that in 2006?
Ensure brevity in your answer.  8.1. What is the ratio of the Debt(current US$) in Low income in 2005 to that in 2007?
Offer a terse response. 0.79. What is the ratio of the Debt(current US$) of Gabon in 2005 to that in 2007?
Offer a very short reply. 0.35. What is the ratio of the Debt(current US$) in Senegal in 2005 to that in 2007?
Make the answer very short. 0.82. What is the ratio of the Debt(current US$) in South Africa in 2005 to that in 2007?
Provide a short and direct response. 8.1. What is the ratio of the Debt(current US$) of Low income in 2005 to that in 2008?
Keep it short and to the point. 0.73. What is the ratio of the Debt(current US$) of Gabon in 2005 to that in 2008?
Your answer should be compact. 0.19. What is the ratio of the Debt(current US$) in Senegal in 2005 to that in 2008?
Offer a very short reply. 0.81. What is the ratio of the Debt(current US$) in South Africa in 2005 to that in 2008?
Give a very brief answer. 14.49. What is the ratio of the Debt(current US$) of Low income in 2005 to that in 2009?
Offer a very short reply. 0.67. What is the ratio of the Debt(current US$) in Gabon in 2005 to that in 2009?
Give a very brief answer. 0.22. What is the ratio of the Debt(current US$) of Senegal in 2005 to that in 2009?
Keep it short and to the point. 0.76. What is the ratio of the Debt(current US$) of South Africa in 2005 to that in 2009?
Ensure brevity in your answer.  0.01. What is the ratio of the Debt(current US$) in Low income in 2005 to that in 2010?
Your answer should be very brief. 0.56. What is the ratio of the Debt(current US$) of Gabon in 2005 to that in 2010?
Ensure brevity in your answer.  0.21. What is the ratio of the Debt(current US$) in Senegal in 2005 to that in 2010?
Your response must be concise. 0.78. What is the ratio of the Debt(current US$) of South Africa in 2005 to that in 2010?
Your answer should be very brief. 0.01. What is the ratio of the Debt(current US$) of Low income in 2006 to that in 2007?
Ensure brevity in your answer.  0.85. What is the ratio of the Debt(current US$) of Gabon in 2006 to that in 2007?
Your answer should be very brief. 0.33. What is the ratio of the Debt(current US$) in Senegal in 2006 to that in 2007?
Keep it short and to the point. 1.05. What is the ratio of the Debt(current US$) in South Africa in 2006 to that in 2007?
Make the answer very short. 1. What is the ratio of the Debt(current US$) of Low income in 2006 to that in 2008?
Your answer should be compact. 0.78. What is the ratio of the Debt(current US$) of Gabon in 2006 to that in 2008?
Provide a succinct answer. 0.18. What is the ratio of the Debt(current US$) of Senegal in 2006 to that in 2008?
Provide a short and direct response. 1.05. What is the ratio of the Debt(current US$) in South Africa in 2006 to that in 2008?
Offer a very short reply. 1.79. What is the ratio of the Debt(current US$) of Low income in 2006 to that in 2009?
Your answer should be very brief. 0.73. What is the ratio of the Debt(current US$) in Gabon in 2006 to that in 2009?
Ensure brevity in your answer.  0.21. What is the ratio of the Debt(current US$) in Senegal in 2006 to that in 2009?
Make the answer very short. 0.98. What is the ratio of the Debt(current US$) in South Africa in 2006 to that in 2009?
Provide a short and direct response. 0. What is the ratio of the Debt(current US$) in Low income in 2006 to that in 2010?
Offer a very short reply. 0.6. What is the ratio of the Debt(current US$) of Gabon in 2006 to that in 2010?
Give a very brief answer. 0.2. What is the ratio of the Debt(current US$) of Senegal in 2006 to that in 2010?
Offer a terse response. 1.01. What is the ratio of the Debt(current US$) of South Africa in 2006 to that in 2010?
Your answer should be very brief. 0. What is the ratio of the Debt(current US$) in Low income in 2007 to that in 2008?
Your answer should be very brief. 0.92. What is the ratio of the Debt(current US$) of Gabon in 2007 to that in 2008?
Offer a very short reply. 0.54. What is the ratio of the Debt(current US$) in South Africa in 2007 to that in 2008?
Give a very brief answer. 1.79. What is the ratio of the Debt(current US$) of Low income in 2007 to that in 2009?
Your response must be concise. 0.85. What is the ratio of the Debt(current US$) of Gabon in 2007 to that in 2009?
Offer a very short reply. 0.64. What is the ratio of the Debt(current US$) in Senegal in 2007 to that in 2009?
Offer a very short reply. 0.92. What is the ratio of the Debt(current US$) in South Africa in 2007 to that in 2009?
Offer a very short reply. 0. What is the ratio of the Debt(current US$) in Low income in 2007 to that in 2010?
Provide a succinct answer. 0.7. What is the ratio of the Debt(current US$) in Gabon in 2007 to that in 2010?
Give a very brief answer. 0.61. What is the ratio of the Debt(current US$) in Senegal in 2007 to that in 2010?
Your answer should be compact. 0.96. What is the ratio of the Debt(current US$) of South Africa in 2007 to that in 2010?
Provide a succinct answer. 0. What is the ratio of the Debt(current US$) in Low income in 2008 to that in 2009?
Keep it short and to the point. 0.93. What is the ratio of the Debt(current US$) of Gabon in 2008 to that in 2009?
Offer a terse response. 1.19. What is the ratio of the Debt(current US$) of Senegal in 2008 to that in 2009?
Provide a short and direct response. 0.93. What is the ratio of the Debt(current US$) of South Africa in 2008 to that in 2009?
Provide a short and direct response. 0. What is the ratio of the Debt(current US$) of Low income in 2008 to that in 2010?
Keep it short and to the point. 0.77. What is the ratio of the Debt(current US$) of Gabon in 2008 to that in 2010?
Offer a terse response. 1.14. What is the ratio of the Debt(current US$) of Senegal in 2008 to that in 2010?
Provide a succinct answer. 0.96. What is the ratio of the Debt(current US$) of South Africa in 2008 to that in 2010?
Make the answer very short. 0. What is the ratio of the Debt(current US$) of Low income in 2009 to that in 2010?
Keep it short and to the point. 0.82. What is the ratio of the Debt(current US$) of Gabon in 2009 to that in 2010?
Provide a short and direct response. 0.96. What is the ratio of the Debt(current US$) in Senegal in 2009 to that in 2010?
Your answer should be very brief. 1.04. What is the difference between the highest and the second highest Debt(current US$) in Low income?
Make the answer very short. 6.20e+09. What is the difference between the highest and the second highest Debt(current US$) in Gabon?
Your answer should be compact. 1.39e+08. What is the difference between the highest and the second highest Debt(current US$) in Senegal?
Offer a terse response. 3.77e+07. What is the difference between the highest and the second highest Debt(current US$) in South Africa?
Offer a terse response. 1.40e+06. What is the difference between the highest and the lowest Debt(current US$) of Low income?
Your response must be concise. 1.66e+1. What is the difference between the highest and the lowest Debt(current US$) of Gabon?
Offer a very short reply. 9.40e+08. What is the difference between the highest and the lowest Debt(current US$) of Senegal?
Offer a terse response. 3.78e+08. What is the difference between the highest and the lowest Debt(current US$) of South Africa?
Offer a very short reply. 5.63e+09. 